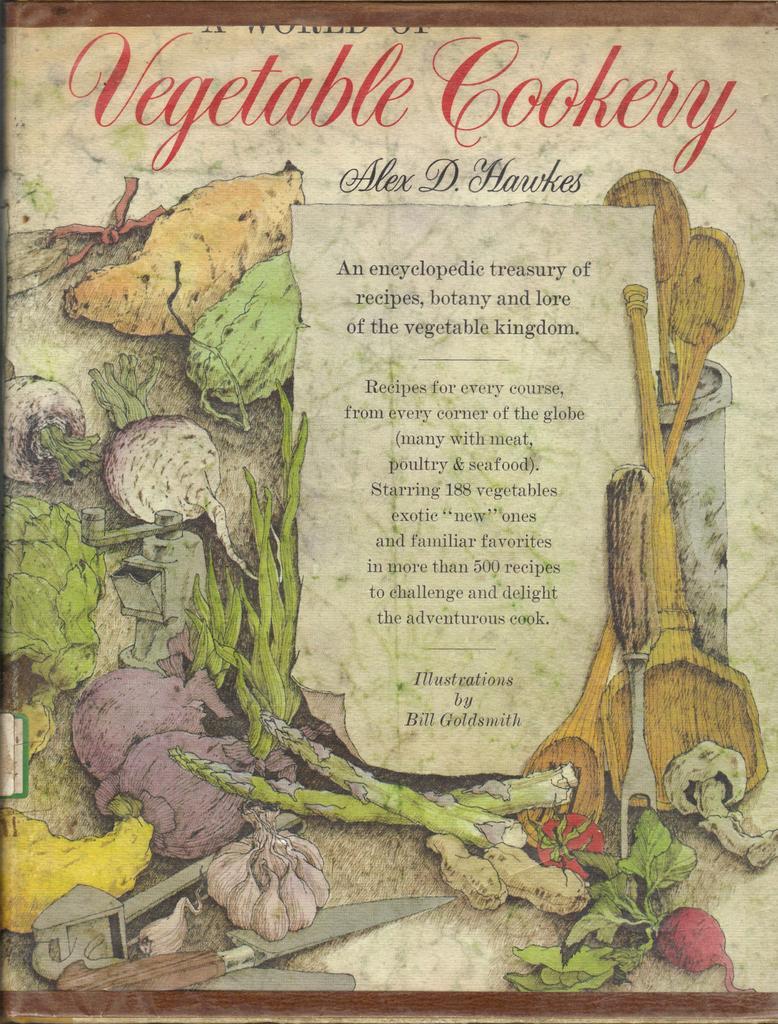How would you summarize this image in a sentence or two? This picture is consists of vegetable cookery poster in the image. 